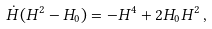Convert formula to latex. <formula><loc_0><loc_0><loc_500><loc_500>\dot { H } ( H ^ { 2 } - H _ { 0 } ) = - H ^ { 4 } + 2 H _ { 0 } H ^ { 2 } \, ,</formula> 